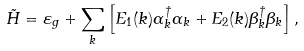Convert formula to latex. <formula><loc_0><loc_0><loc_500><loc_500>\tilde { H } = \varepsilon _ { g } + \sum _ { k } \left [ E _ { 1 } ( k ) \alpha _ { k } ^ { \dagger } \alpha _ { k } + E _ { 2 } ( k ) \beta _ { k } ^ { \dagger } \beta _ { k } \right ] ,</formula> 